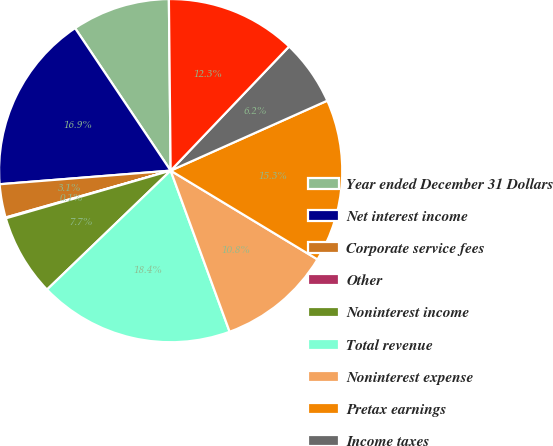Convert chart. <chart><loc_0><loc_0><loc_500><loc_500><pie_chart><fcel>Year ended December 31 Dollars<fcel>Net interest income<fcel>Corporate service fees<fcel>Other<fcel>Noninterest income<fcel>Total revenue<fcel>Noninterest expense<fcel>Pretax earnings<fcel>Income taxes<fcel>Earnings<nl><fcel>9.24%<fcel>16.86%<fcel>3.14%<fcel>0.08%<fcel>7.71%<fcel>18.39%<fcel>10.76%<fcel>15.34%<fcel>6.19%<fcel>12.29%<nl></chart> 